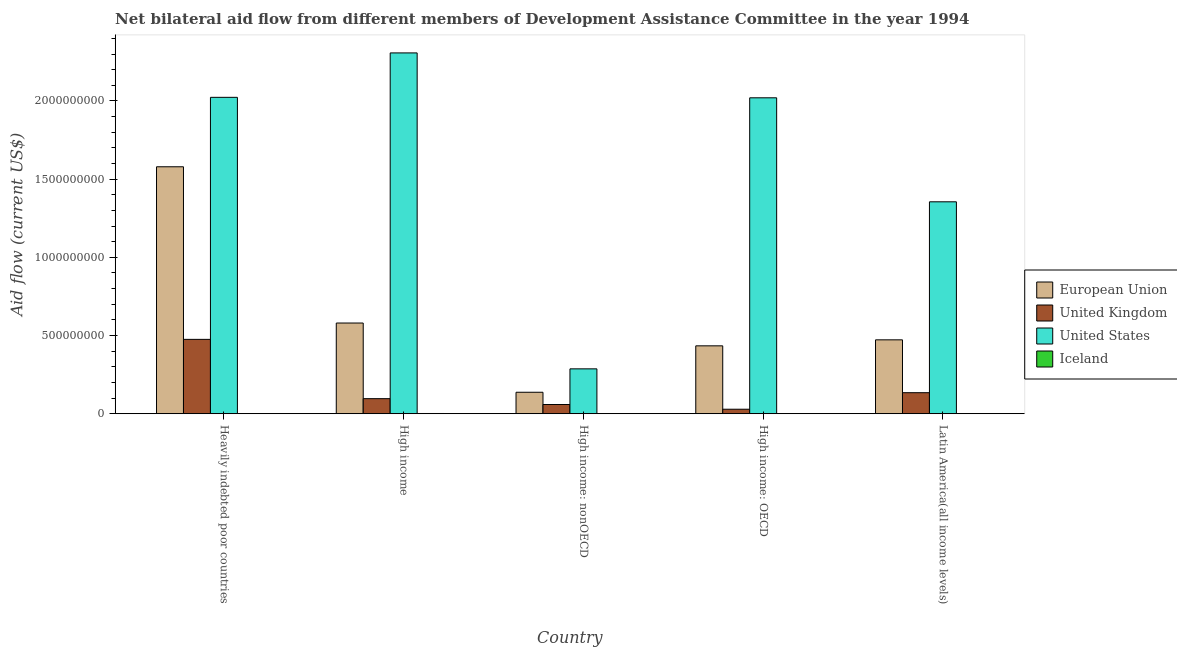What is the label of the 3rd group of bars from the left?
Your answer should be compact. High income: nonOECD. In how many cases, is the number of bars for a given country not equal to the number of legend labels?
Your answer should be very brief. 0. What is the amount of aid given by eu in Latin America(all income levels)?
Provide a succinct answer. 4.73e+08. Across all countries, what is the maximum amount of aid given by uk?
Keep it short and to the point. 4.76e+08. Across all countries, what is the minimum amount of aid given by iceland?
Your answer should be very brief. 3.40e+05. In which country was the amount of aid given by us minimum?
Your answer should be compact. High income: nonOECD. What is the total amount of aid given by us in the graph?
Make the answer very short. 7.99e+09. What is the difference between the amount of aid given by iceland in Heavily indebted poor countries and that in High income?
Provide a succinct answer. -8.10e+05. What is the difference between the amount of aid given by eu in Heavily indebted poor countries and the amount of aid given by iceland in High income?
Give a very brief answer. 1.58e+09. What is the average amount of aid given by eu per country?
Ensure brevity in your answer.  6.41e+08. What is the difference between the amount of aid given by uk and amount of aid given by us in Latin America(all income levels)?
Ensure brevity in your answer.  -1.22e+09. What is the ratio of the amount of aid given by eu in High income: OECD to that in Latin America(all income levels)?
Offer a terse response. 0.92. What is the difference between the highest and the second highest amount of aid given by uk?
Offer a terse response. 3.41e+08. What is the difference between the highest and the lowest amount of aid given by uk?
Your answer should be very brief. 4.47e+08. In how many countries, is the amount of aid given by iceland greater than the average amount of aid given by iceland taken over all countries?
Offer a terse response. 1. What does the 4th bar from the right in High income: OECD represents?
Offer a terse response. European Union. Where does the legend appear in the graph?
Offer a very short reply. Center right. What is the title of the graph?
Give a very brief answer. Net bilateral aid flow from different members of Development Assistance Committee in the year 1994. What is the Aid flow (current US$) in European Union in Heavily indebted poor countries?
Offer a terse response. 1.58e+09. What is the Aid flow (current US$) of United Kingdom in Heavily indebted poor countries?
Your answer should be very brief. 4.76e+08. What is the Aid flow (current US$) of United States in Heavily indebted poor countries?
Make the answer very short. 2.02e+09. What is the Aid flow (current US$) of Iceland in Heavily indebted poor countries?
Keep it short and to the point. 8.00e+05. What is the Aid flow (current US$) in European Union in High income?
Your answer should be compact. 5.80e+08. What is the Aid flow (current US$) in United Kingdom in High income?
Provide a short and direct response. 9.64e+07. What is the Aid flow (current US$) in United States in High income?
Your answer should be very brief. 2.31e+09. What is the Aid flow (current US$) of Iceland in High income?
Provide a succinct answer. 1.61e+06. What is the Aid flow (current US$) of European Union in High income: nonOECD?
Make the answer very short. 1.37e+08. What is the Aid flow (current US$) in United Kingdom in High income: nonOECD?
Keep it short and to the point. 5.90e+07. What is the Aid flow (current US$) of United States in High income: nonOECD?
Ensure brevity in your answer.  2.87e+08. What is the Aid flow (current US$) in European Union in High income: OECD?
Make the answer very short. 4.34e+08. What is the Aid flow (current US$) of United Kingdom in High income: OECD?
Provide a succinct answer. 2.88e+07. What is the Aid flow (current US$) in United States in High income: OECD?
Provide a succinct answer. 2.02e+09. What is the Aid flow (current US$) of Iceland in High income: OECD?
Provide a short and direct response. 3.40e+05. What is the Aid flow (current US$) in European Union in Latin America(all income levels)?
Your response must be concise. 4.73e+08. What is the Aid flow (current US$) of United Kingdom in Latin America(all income levels)?
Give a very brief answer. 1.35e+08. What is the Aid flow (current US$) in United States in Latin America(all income levels)?
Your answer should be compact. 1.36e+09. Across all countries, what is the maximum Aid flow (current US$) in European Union?
Provide a succinct answer. 1.58e+09. Across all countries, what is the maximum Aid flow (current US$) in United Kingdom?
Your answer should be very brief. 4.76e+08. Across all countries, what is the maximum Aid flow (current US$) in United States?
Make the answer very short. 2.31e+09. Across all countries, what is the maximum Aid flow (current US$) in Iceland?
Make the answer very short. 1.61e+06. Across all countries, what is the minimum Aid flow (current US$) in European Union?
Your answer should be very brief. 1.37e+08. Across all countries, what is the minimum Aid flow (current US$) of United Kingdom?
Make the answer very short. 2.88e+07. Across all countries, what is the minimum Aid flow (current US$) in United States?
Provide a short and direct response. 2.87e+08. What is the total Aid flow (current US$) of European Union in the graph?
Offer a very short reply. 3.20e+09. What is the total Aid flow (current US$) of United Kingdom in the graph?
Your answer should be very brief. 7.94e+08. What is the total Aid flow (current US$) in United States in the graph?
Keep it short and to the point. 7.99e+09. What is the total Aid flow (current US$) in Iceland in the graph?
Give a very brief answer. 4.02e+06. What is the difference between the Aid flow (current US$) of European Union in Heavily indebted poor countries and that in High income?
Make the answer very short. 9.99e+08. What is the difference between the Aid flow (current US$) of United Kingdom in Heavily indebted poor countries and that in High income?
Your answer should be very brief. 3.79e+08. What is the difference between the Aid flow (current US$) of United States in Heavily indebted poor countries and that in High income?
Your answer should be compact. -2.84e+08. What is the difference between the Aid flow (current US$) of Iceland in Heavily indebted poor countries and that in High income?
Provide a succinct answer. -8.10e+05. What is the difference between the Aid flow (current US$) in European Union in Heavily indebted poor countries and that in High income: nonOECD?
Your answer should be compact. 1.44e+09. What is the difference between the Aid flow (current US$) in United Kingdom in Heavily indebted poor countries and that in High income: nonOECD?
Give a very brief answer. 4.17e+08. What is the difference between the Aid flow (current US$) in United States in Heavily indebted poor countries and that in High income: nonOECD?
Your response must be concise. 1.74e+09. What is the difference between the Aid flow (current US$) of European Union in Heavily indebted poor countries and that in High income: OECD?
Offer a very short reply. 1.14e+09. What is the difference between the Aid flow (current US$) in United Kingdom in Heavily indebted poor countries and that in High income: OECD?
Your response must be concise. 4.47e+08. What is the difference between the Aid flow (current US$) in United States in Heavily indebted poor countries and that in High income: OECD?
Provide a short and direct response. 3.00e+06. What is the difference between the Aid flow (current US$) of Iceland in Heavily indebted poor countries and that in High income: OECD?
Give a very brief answer. 4.60e+05. What is the difference between the Aid flow (current US$) of European Union in Heavily indebted poor countries and that in Latin America(all income levels)?
Ensure brevity in your answer.  1.11e+09. What is the difference between the Aid flow (current US$) in United Kingdom in Heavily indebted poor countries and that in Latin America(all income levels)?
Provide a succinct answer. 3.41e+08. What is the difference between the Aid flow (current US$) of United States in Heavily indebted poor countries and that in Latin America(all income levels)?
Give a very brief answer. 6.68e+08. What is the difference between the Aid flow (current US$) in Iceland in Heavily indebted poor countries and that in Latin America(all income levels)?
Keep it short and to the point. 0. What is the difference between the Aid flow (current US$) in European Union in High income and that in High income: nonOECD?
Keep it short and to the point. 4.43e+08. What is the difference between the Aid flow (current US$) of United Kingdom in High income and that in High income: nonOECD?
Your response must be concise. 3.74e+07. What is the difference between the Aid flow (current US$) in United States in High income and that in High income: nonOECD?
Your answer should be compact. 2.02e+09. What is the difference between the Aid flow (current US$) of Iceland in High income and that in High income: nonOECD?
Your answer should be very brief. 1.14e+06. What is the difference between the Aid flow (current US$) of European Union in High income and that in High income: OECD?
Provide a succinct answer. 1.46e+08. What is the difference between the Aid flow (current US$) of United Kingdom in High income and that in High income: OECD?
Ensure brevity in your answer.  6.76e+07. What is the difference between the Aid flow (current US$) in United States in High income and that in High income: OECD?
Offer a very short reply. 2.87e+08. What is the difference between the Aid flow (current US$) of Iceland in High income and that in High income: OECD?
Offer a terse response. 1.27e+06. What is the difference between the Aid flow (current US$) of European Union in High income and that in Latin America(all income levels)?
Ensure brevity in your answer.  1.07e+08. What is the difference between the Aid flow (current US$) of United Kingdom in High income and that in Latin America(all income levels)?
Give a very brief answer. -3.81e+07. What is the difference between the Aid flow (current US$) of United States in High income and that in Latin America(all income levels)?
Ensure brevity in your answer.  9.52e+08. What is the difference between the Aid flow (current US$) in Iceland in High income and that in Latin America(all income levels)?
Offer a very short reply. 8.10e+05. What is the difference between the Aid flow (current US$) in European Union in High income: nonOECD and that in High income: OECD?
Offer a very short reply. -2.97e+08. What is the difference between the Aid flow (current US$) in United Kingdom in High income: nonOECD and that in High income: OECD?
Give a very brief answer. 3.01e+07. What is the difference between the Aid flow (current US$) in United States in High income: nonOECD and that in High income: OECD?
Your answer should be compact. -1.73e+09. What is the difference between the Aid flow (current US$) of Iceland in High income: nonOECD and that in High income: OECD?
Provide a succinct answer. 1.30e+05. What is the difference between the Aid flow (current US$) in European Union in High income: nonOECD and that in Latin America(all income levels)?
Your response must be concise. -3.35e+08. What is the difference between the Aid flow (current US$) in United Kingdom in High income: nonOECD and that in Latin America(all income levels)?
Your response must be concise. -7.56e+07. What is the difference between the Aid flow (current US$) in United States in High income: nonOECD and that in Latin America(all income levels)?
Offer a terse response. -1.07e+09. What is the difference between the Aid flow (current US$) of Iceland in High income: nonOECD and that in Latin America(all income levels)?
Your answer should be compact. -3.30e+05. What is the difference between the Aid flow (current US$) in European Union in High income: OECD and that in Latin America(all income levels)?
Offer a very short reply. -3.83e+07. What is the difference between the Aid flow (current US$) of United Kingdom in High income: OECD and that in Latin America(all income levels)?
Your answer should be very brief. -1.06e+08. What is the difference between the Aid flow (current US$) of United States in High income: OECD and that in Latin America(all income levels)?
Your answer should be compact. 6.65e+08. What is the difference between the Aid flow (current US$) in Iceland in High income: OECD and that in Latin America(all income levels)?
Offer a very short reply. -4.60e+05. What is the difference between the Aid flow (current US$) in European Union in Heavily indebted poor countries and the Aid flow (current US$) in United Kingdom in High income?
Give a very brief answer. 1.48e+09. What is the difference between the Aid flow (current US$) of European Union in Heavily indebted poor countries and the Aid flow (current US$) of United States in High income?
Ensure brevity in your answer.  -7.28e+08. What is the difference between the Aid flow (current US$) of European Union in Heavily indebted poor countries and the Aid flow (current US$) of Iceland in High income?
Provide a short and direct response. 1.58e+09. What is the difference between the Aid flow (current US$) of United Kingdom in Heavily indebted poor countries and the Aid flow (current US$) of United States in High income?
Provide a short and direct response. -1.83e+09. What is the difference between the Aid flow (current US$) in United Kingdom in Heavily indebted poor countries and the Aid flow (current US$) in Iceland in High income?
Your response must be concise. 4.74e+08. What is the difference between the Aid flow (current US$) in United States in Heavily indebted poor countries and the Aid flow (current US$) in Iceland in High income?
Offer a terse response. 2.02e+09. What is the difference between the Aid flow (current US$) of European Union in Heavily indebted poor countries and the Aid flow (current US$) of United Kingdom in High income: nonOECD?
Make the answer very short. 1.52e+09. What is the difference between the Aid flow (current US$) of European Union in Heavily indebted poor countries and the Aid flow (current US$) of United States in High income: nonOECD?
Offer a terse response. 1.29e+09. What is the difference between the Aid flow (current US$) of European Union in Heavily indebted poor countries and the Aid flow (current US$) of Iceland in High income: nonOECD?
Offer a terse response. 1.58e+09. What is the difference between the Aid flow (current US$) of United Kingdom in Heavily indebted poor countries and the Aid flow (current US$) of United States in High income: nonOECD?
Offer a terse response. 1.88e+08. What is the difference between the Aid flow (current US$) of United Kingdom in Heavily indebted poor countries and the Aid flow (current US$) of Iceland in High income: nonOECD?
Offer a very short reply. 4.75e+08. What is the difference between the Aid flow (current US$) of United States in Heavily indebted poor countries and the Aid flow (current US$) of Iceland in High income: nonOECD?
Give a very brief answer. 2.02e+09. What is the difference between the Aid flow (current US$) in European Union in Heavily indebted poor countries and the Aid flow (current US$) in United Kingdom in High income: OECD?
Give a very brief answer. 1.55e+09. What is the difference between the Aid flow (current US$) of European Union in Heavily indebted poor countries and the Aid flow (current US$) of United States in High income: OECD?
Provide a succinct answer. -4.41e+08. What is the difference between the Aid flow (current US$) in European Union in Heavily indebted poor countries and the Aid flow (current US$) in Iceland in High income: OECD?
Your answer should be very brief. 1.58e+09. What is the difference between the Aid flow (current US$) of United Kingdom in Heavily indebted poor countries and the Aid flow (current US$) of United States in High income: OECD?
Your response must be concise. -1.54e+09. What is the difference between the Aid flow (current US$) in United Kingdom in Heavily indebted poor countries and the Aid flow (current US$) in Iceland in High income: OECD?
Offer a very short reply. 4.75e+08. What is the difference between the Aid flow (current US$) of United States in Heavily indebted poor countries and the Aid flow (current US$) of Iceland in High income: OECD?
Ensure brevity in your answer.  2.02e+09. What is the difference between the Aid flow (current US$) of European Union in Heavily indebted poor countries and the Aid flow (current US$) of United Kingdom in Latin America(all income levels)?
Keep it short and to the point. 1.44e+09. What is the difference between the Aid flow (current US$) of European Union in Heavily indebted poor countries and the Aid flow (current US$) of United States in Latin America(all income levels)?
Your answer should be compact. 2.24e+08. What is the difference between the Aid flow (current US$) in European Union in Heavily indebted poor countries and the Aid flow (current US$) in Iceland in Latin America(all income levels)?
Provide a succinct answer. 1.58e+09. What is the difference between the Aid flow (current US$) of United Kingdom in Heavily indebted poor countries and the Aid flow (current US$) of United States in Latin America(all income levels)?
Offer a very short reply. -8.80e+08. What is the difference between the Aid flow (current US$) in United Kingdom in Heavily indebted poor countries and the Aid flow (current US$) in Iceland in Latin America(all income levels)?
Keep it short and to the point. 4.75e+08. What is the difference between the Aid flow (current US$) in United States in Heavily indebted poor countries and the Aid flow (current US$) in Iceland in Latin America(all income levels)?
Keep it short and to the point. 2.02e+09. What is the difference between the Aid flow (current US$) of European Union in High income and the Aid flow (current US$) of United Kingdom in High income: nonOECD?
Make the answer very short. 5.21e+08. What is the difference between the Aid flow (current US$) in European Union in High income and the Aid flow (current US$) in United States in High income: nonOECD?
Your answer should be very brief. 2.93e+08. What is the difference between the Aid flow (current US$) in European Union in High income and the Aid flow (current US$) in Iceland in High income: nonOECD?
Your answer should be compact. 5.80e+08. What is the difference between the Aid flow (current US$) in United Kingdom in High income and the Aid flow (current US$) in United States in High income: nonOECD?
Provide a short and direct response. -1.91e+08. What is the difference between the Aid flow (current US$) in United Kingdom in High income and the Aid flow (current US$) in Iceland in High income: nonOECD?
Ensure brevity in your answer.  9.59e+07. What is the difference between the Aid flow (current US$) of United States in High income and the Aid flow (current US$) of Iceland in High income: nonOECD?
Your answer should be compact. 2.31e+09. What is the difference between the Aid flow (current US$) in European Union in High income and the Aid flow (current US$) in United Kingdom in High income: OECD?
Your answer should be very brief. 5.51e+08. What is the difference between the Aid flow (current US$) of European Union in High income and the Aid flow (current US$) of United States in High income: OECD?
Your answer should be very brief. -1.44e+09. What is the difference between the Aid flow (current US$) in European Union in High income and the Aid flow (current US$) in Iceland in High income: OECD?
Keep it short and to the point. 5.80e+08. What is the difference between the Aid flow (current US$) of United Kingdom in High income and the Aid flow (current US$) of United States in High income: OECD?
Offer a terse response. -1.92e+09. What is the difference between the Aid flow (current US$) of United Kingdom in High income and the Aid flow (current US$) of Iceland in High income: OECD?
Make the answer very short. 9.61e+07. What is the difference between the Aid flow (current US$) of United States in High income and the Aid flow (current US$) of Iceland in High income: OECD?
Your answer should be very brief. 2.31e+09. What is the difference between the Aid flow (current US$) of European Union in High income and the Aid flow (current US$) of United Kingdom in Latin America(all income levels)?
Offer a terse response. 4.45e+08. What is the difference between the Aid flow (current US$) in European Union in High income and the Aid flow (current US$) in United States in Latin America(all income levels)?
Keep it short and to the point. -7.75e+08. What is the difference between the Aid flow (current US$) in European Union in High income and the Aid flow (current US$) in Iceland in Latin America(all income levels)?
Give a very brief answer. 5.79e+08. What is the difference between the Aid flow (current US$) of United Kingdom in High income and the Aid flow (current US$) of United States in Latin America(all income levels)?
Ensure brevity in your answer.  -1.26e+09. What is the difference between the Aid flow (current US$) in United Kingdom in High income and the Aid flow (current US$) in Iceland in Latin America(all income levels)?
Provide a succinct answer. 9.56e+07. What is the difference between the Aid flow (current US$) in United States in High income and the Aid flow (current US$) in Iceland in Latin America(all income levels)?
Provide a succinct answer. 2.31e+09. What is the difference between the Aid flow (current US$) of European Union in High income: nonOECD and the Aid flow (current US$) of United Kingdom in High income: OECD?
Offer a very short reply. 1.08e+08. What is the difference between the Aid flow (current US$) in European Union in High income: nonOECD and the Aid flow (current US$) in United States in High income: OECD?
Offer a terse response. -1.88e+09. What is the difference between the Aid flow (current US$) of European Union in High income: nonOECD and the Aid flow (current US$) of Iceland in High income: OECD?
Your answer should be compact. 1.37e+08. What is the difference between the Aid flow (current US$) of United Kingdom in High income: nonOECD and the Aid flow (current US$) of United States in High income: OECD?
Give a very brief answer. -1.96e+09. What is the difference between the Aid flow (current US$) in United Kingdom in High income: nonOECD and the Aid flow (current US$) in Iceland in High income: OECD?
Your answer should be compact. 5.86e+07. What is the difference between the Aid flow (current US$) of United States in High income: nonOECD and the Aid flow (current US$) of Iceland in High income: OECD?
Ensure brevity in your answer.  2.87e+08. What is the difference between the Aid flow (current US$) in European Union in High income: nonOECD and the Aid flow (current US$) in United Kingdom in Latin America(all income levels)?
Your answer should be very brief. 2.79e+06. What is the difference between the Aid flow (current US$) in European Union in High income: nonOECD and the Aid flow (current US$) in United States in Latin America(all income levels)?
Provide a succinct answer. -1.22e+09. What is the difference between the Aid flow (current US$) in European Union in High income: nonOECD and the Aid flow (current US$) in Iceland in Latin America(all income levels)?
Make the answer very short. 1.37e+08. What is the difference between the Aid flow (current US$) of United Kingdom in High income: nonOECD and the Aid flow (current US$) of United States in Latin America(all income levels)?
Make the answer very short. -1.30e+09. What is the difference between the Aid flow (current US$) in United Kingdom in High income: nonOECD and the Aid flow (current US$) in Iceland in Latin America(all income levels)?
Your answer should be very brief. 5.82e+07. What is the difference between the Aid flow (current US$) of United States in High income: nonOECD and the Aid flow (current US$) of Iceland in Latin America(all income levels)?
Offer a terse response. 2.86e+08. What is the difference between the Aid flow (current US$) in European Union in High income: OECD and the Aid flow (current US$) in United Kingdom in Latin America(all income levels)?
Provide a succinct answer. 3.00e+08. What is the difference between the Aid flow (current US$) of European Union in High income: OECD and the Aid flow (current US$) of United States in Latin America(all income levels)?
Make the answer very short. -9.21e+08. What is the difference between the Aid flow (current US$) of European Union in High income: OECD and the Aid flow (current US$) of Iceland in Latin America(all income levels)?
Your answer should be very brief. 4.33e+08. What is the difference between the Aid flow (current US$) in United Kingdom in High income: OECD and the Aid flow (current US$) in United States in Latin America(all income levels)?
Offer a very short reply. -1.33e+09. What is the difference between the Aid flow (current US$) of United Kingdom in High income: OECD and the Aid flow (current US$) of Iceland in Latin America(all income levels)?
Ensure brevity in your answer.  2.80e+07. What is the difference between the Aid flow (current US$) of United States in High income: OECD and the Aid flow (current US$) of Iceland in Latin America(all income levels)?
Your answer should be very brief. 2.02e+09. What is the average Aid flow (current US$) in European Union per country?
Your response must be concise. 6.41e+08. What is the average Aid flow (current US$) of United Kingdom per country?
Give a very brief answer. 1.59e+08. What is the average Aid flow (current US$) of United States per country?
Provide a short and direct response. 1.60e+09. What is the average Aid flow (current US$) of Iceland per country?
Ensure brevity in your answer.  8.04e+05. What is the difference between the Aid flow (current US$) of European Union and Aid flow (current US$) of United Kingdom in Heavily indebted poor countries?
Offer a terse response. 1.10e+09. What is the difference between the Aid flow (current US$) in European Union and Aid flow (current US$) in United States in Heavily indebted poor countries?
Give a very brief answer. -4.44e+08. What is the difference between the Aid flow (current US$) of European Union and Aid flow (current US$) of Iceland in Heavily indebted poor countries?
Your answer should be compact. 1.58e+09. What is the difference between the Aid flow (current US$) of United Kingdom and Aid flow (current US$) of United States in Heavily indebted poor countries?
Offer a very short reply. -1.55e+09. What is the difference between the Aid flow (current US$) of United Kingdom and Aid flow (current US$) of Iceland in Heavily indebted poor countries?
Offer a very short reply. 4.75e+08. What is the difference between the Aid flow (current US$) in United States and Aid flow (current US$) in Iceland in Heavily indebted poor countries?
Offer a terse response. 2.02e+09. What is the difference between the Aid flow (current US$) of European Union and Aid flow (current US$) of United Kingdom in High income?
Keep it short and to the point. 4.84e+08. What is the difference between the Aid flow (current US$) of European Union and Aid flow (current US$) of United States in High income?
Offer a terse response. -1.73e+09. What is the difference between the Aid flow (current US$) of European Union and Aid flow (current US$) of Iceland in High income?
Keep it short and to the point. 5.78e+08. What is the difference between the Aid flow (current US$) in United Kingdom and Aid flow (current US$) in United States in High income?
Provide a succinct answer. -2.21e+09. What is the difference between the Aid flow (current US$) in United Kingdom and Aid flow (current US$) in Iceland in High income?
Provide a short and direct response. 9.48e+07. What is the difference between the Aid flow (current US$) of United States and Aid flow (current US$) of Iceland in High income?
Your answer should be compact. 2.31e+09. What is the difference between the Aid flow (current US$) of European Union and Aid flow (current US$) of United Kingdom in High income: nonOECD?
Your answer should be compact. 7.84e+07. What is the difference between the Aid flow (current US$) of European Union and Aid flow (current US$) of United States in High income: nonOECD?
Your answer should be compact. -1.50e+08. What is the difference between the Aid flow (current US$) of European Union and Aid flow (current US$) of Iceland in High income: nonOECD?
Give a very brief answer. 1.37e+08. What is the difference between the Aid flow (current US$) of United Kingdom and Aid flow (current US$) of United States in High income: nonOECD?
Ensure brevity in your answer.  -2.28e+08. What is the difference between the Aid flow (current US$) in United Kingdom and Aid flow (current US$) in Iceland in High income: nonOECD?
Give a very brief answer. 5.85e+07. What is the difference between the Aid flow (current US$) of United States and Aid flow (current US$) of Iceland in High income: nonOECD?
Your response must be concise. 2.87e+08. What is the difference between the Aid flow (current US$) of European Union and Aid flow (current US$) of United Kingdom in High income: OECD?
Offer a very short reply. 4.05e+08. What is the difference between the Aid flow (current US$) in European Union and Aid flow (current US$) in United States in High income: OECD?
Make the answer very short. -1.59e+09. What is the difference between the Aid flow (current US$) in European Union and Aid flow (current US$) in Iceland in High income: OECD?
Provide a succinct answer. 4.34e+08. What is the difference between the Aid flow (current US$) in United Kingdom and Aid flow (current US$) in United States in High income: OECD?
Your answer should be compact. -1.99e+09. What is the difference between the Aid flow (current US$) in United Kingdom and Aid flow (current US$) in Iceland in High income: OECD?
Ensure brevity in your answer.  2.85e+07. What is the difference between the Aid flow (current US$) of United States and Aid flow (current US$) of Iceland in High income: OECD?
Make the answer very short. 2.02e+09. What is the difference between the Aid flow (current US$) in European Union and Aid flow (current US$) in United Kingdom in Latin America(all income levels)?
Keep it short and to the point. 3.38e+08. What is the difference between the Aid flow (current US$) of European Union and Aid flow (current US$) of United States in Latin America(all income levels)?
Provide a short and direct response. -8.82e+08. What is the difference between the Aid flow (current US$) in European Union and Aid flow (current US$) in Iceland in Latin America(all income levels)?
Keep it short and to the point. 4.72e+08. What is the difference between the Aid flow (current US$) of United Kingdom and Aid flow (current US$) of United States in Latin America(all income levels)?
Your answer should be compact. -1.22e+09. What is the difference between the Aid flow (current US$) in United Kingdom and Aid flow (current US$) in Iceland in Latin America(all income levels)?
Offer a very short reply. 1.34e+08. What is the difference between the Aid flow (current US$) of United States and Aid flow (current US$) of Iceland in Latin America(all income levels)?
Offer a very short reply. 1.35e+09. What is the ratio of the Aid flow (current US$) in European Union in Heavily indebted poor countries to that in High income?
Ensure brevity in your answer.  2.72. What is the ratio of the Aid flow (current US$) of United Kingdom in Heavily indebted poor countries to that in High income?
Your answer should be compact. 4.93. What is the ratio of the Aid flow (current US$) in United States in Heavily indebted poor countries to that in High income?
Your answer should be compact. 0.88. What is the ratio of the Aid flow (current US$) of Iceland in Heavily indebted poor countries to that in High income?
Offer a terse response. 0.5. What is the ratio of the Aid flow (current US$) of European Union in Heavily indebted poor countries to that in High income: nonOECD?
Offer a terse response. 11.5. What is the ratio of the Aid flow (current US$) of United Kingdom in Heavily indebted poor countries to that in High income: nonOECD?
Provide a short and direct response. 8.06. What is the ratio of the Aid flow (current US$) of United States in Heavily indebted poor countries to that in High income: nonOECD?
Provide a succinct answer. 7.05. What is the ratio of the Aid flow (current US$) in Iceland in Heavily indebted poor countries to that in High income: nonOECD?
Provide a succinct answer. 1.7. What is the ratio of the Aid flow (current US$) of European Union in Heavily indebted poor countries to that in High income: OECD?
Offer a terse response. 3.64. What is the ratio of the Aid flow (current US$) in United Kingdom in Heavily indebted poor countries to that in High income: OECD?
Your response must be concise. 16.48. What is the ratio of the Aid flow (current US$) in United States in Heavily indebted poor countries to that in High income: OECD?
Give a very brief answer. 1. What is the ratio of the Aid flow (current US$) in Iceland in Heavily indebted poor countries to that in High income: OECD?
Offer a terse response. 2.35. What is the ratio of the Aid flow (current US$) in European Union in Heavily indebted poor countries to that in Latin America(all income levels)?
Keep it short and to the point. 3.34. What is the ratio of the Aid flow (current US$) in United Kingdom in Heavily indebted poor countries to that in Latin America(all income levels)?
Keep it short and to the point. 3.53. What is the ratio of the Aid flow (current US$) in United States in Heavily indebted poor countries to that in Latin America(all income levels)?
Offer a terse response. 1.49. What is the ratio of the Aid flow (current US$) in Iceland in Heavily indebted poor countries to that in Latin America(all income levels)?
Provide a short and direct response. 1. What is the ratio of the Aid flow (current US$) in European Union in High income to that in High income: nonOECD?
Offer a very short reply. 4.22. What is the ratio of the Aid flow (current US$) of United Kingdom in High income to that in High income: nonOECD?
Your answer should be very brief. 1.63. What is the ratio of the Aid flow (current US$) of United States in High income to that in High income: nonOECD?
Offer a terse response. 8.04. What is the ratio of the Aid flow (current US$) in Iceland in High income to that in High income: nonOECD?
Provide a short and direct response. 3.43. What is the ratio of the Aid flow (current US$) in European Union in High income to that in High income: OECD?
Make the answer very short. 1.34. What is the ratio of the Aid flow (current US$) in United Kingdom in High income to that in High income: OECD?
Give a very brief answer. 3.34. What is the ratio of the Aid flow (current US$) of United States in High income to that in High income: OECD?
Offer a very short reply. 1.14. What is the ratio of the Aid flow (current US$) of Iceland in High income to that in High income: OECD?
Offer a terse response. 4.74. What is the ratio of the Aid flow (current US$) in European Union in High income to that in Latin America(all income levels)?
Your answer should be very brief. 1.23. What is the ratio of the Aid flow (current US$) in United Kingdom in High income to that in Latin America(all income levels)?
Your answer should be very brief. 0.72. What is the ratio of the Aid flow (current US$) in United States in High income to that in Latin America(all income levels)?
Your answer should be very brief. 1.7. What is the ratio of the Aid flow (current US$) of Iceland in High income to that in Latin America(all income levels)?
Your answer should be very brief. 2.01. What is the ratio of the Aid flow (current US$) in European Union in High income: nonOECD to that in High income: OECD?
Your answer should be compact. 0.32. What is the ratio of the Aid flow (current US$) of United Kingdom in High income: nonOECD to that in High income: OECD?
Your response must be concise. 2.04. What is the ratio of the Aid flow (current US$) in United States in High income: nonOECD to that in High income: OECD?
Provide a succinct answer. 0.14. What is the ratio of the Aid flow (current US$) in Iceland in High income: nonOECD to that in High income: OECD?
Your answer should be very brief. 1.38. What is the ratio of the Aid flow (current US$) of European Union in High income: nonOECD to that in Latin America(all income levels)?
Keep it short and to the point. 0.29. What is the ratio of the Aid flow (current US$) in United Kingdom in High income: nonOECD to that in Latin America(all income levels)?
Make the answer very short. 0.44. What is the ratio of the Aid flow (current US$) in United States in High income: nonOECD to that in Latin America(all income levels)?
Make the answer very short. 0.21. What is the ratio of the Aid flow (current US$) of Iceland in High income: nonOECD to that in Latin America(all income levels)?
Ensure brevity in your answer.  0.59. What is the ratio of the Aid flow (current US$) in European Union in High income: OECD to that in Latin America(all income levels)?
Your response must be concise. 0.92. What is the ratio of the Aid flow (current US$) in United Kingdom in High income: OECD to that in Latin America(all income levels)?
Offer a very short reply. 0.21. What is the ratio of the Aid flow (current US$) in United States in High income: OECD to that in Latin America(all income levels)?
Offer a very short reply. 1.49. What is the ratio of the Aid flow (current US$) of Iceland in High income: OECD to that in Latin America(all income levels)?
Ensure brevity in your answer.  0.42. What is the difference between the highest and the second highest Aid flow (current US$) in European Union?
Provide a succinct answer. 9.99e+08. What is the difference between the highest and the second highest Aid flow (current US$) of United Kingdom?
Offer a very short reply. 3.41e+08. What is the difference between the highest and the second highest Aid flow (current US$) in United States?
Your answer should be compact. 2.84e+08. What is the difference between the highest and the second highest Aid flow (current US$) of Iceland?
Provide a short and direct response. 8.10e+05. What is the difference between the highest and the lowest Aid flow (current US$) in European Union?
Keep it short and to the point. 1.44e+09. What is the difference between the highest and the lowest Aid flow (current US$) in United Kingdom?
Your answer should be very brief. 4.47e+08. What is the difference between the highest and the lowest Aid flow (current US$) in United States?
Your answer should be compact. 2.02e+09. What is the difference between the highest and the lowest Aid flow (current US$) in Iceland?
Your answer should be compact. 1.27e+06. 